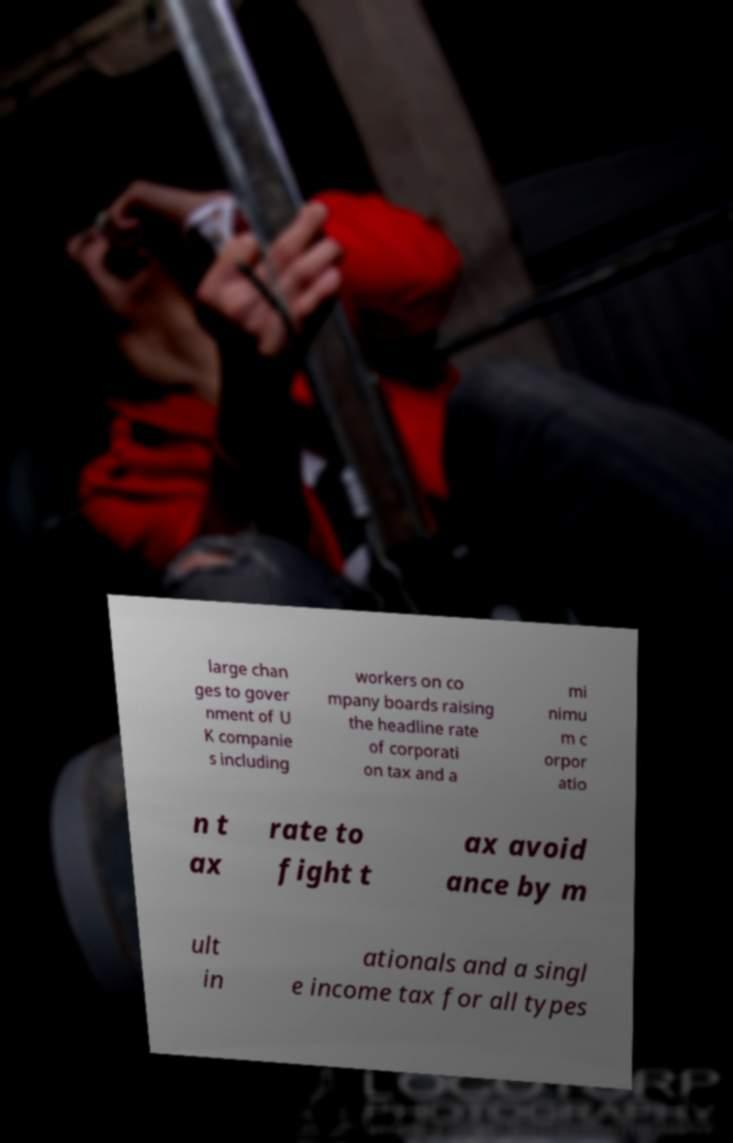Can you accurately transcribe the text from the provided image for me? large chan ges to gover nment of U K companie s including workers on co mpany boards raising the headline rate of corporati on tax and a mi nimu m c orpor atio n t ax rate to fight t ax avoid ance by m ult in ationals and a singl e income tax for all types 